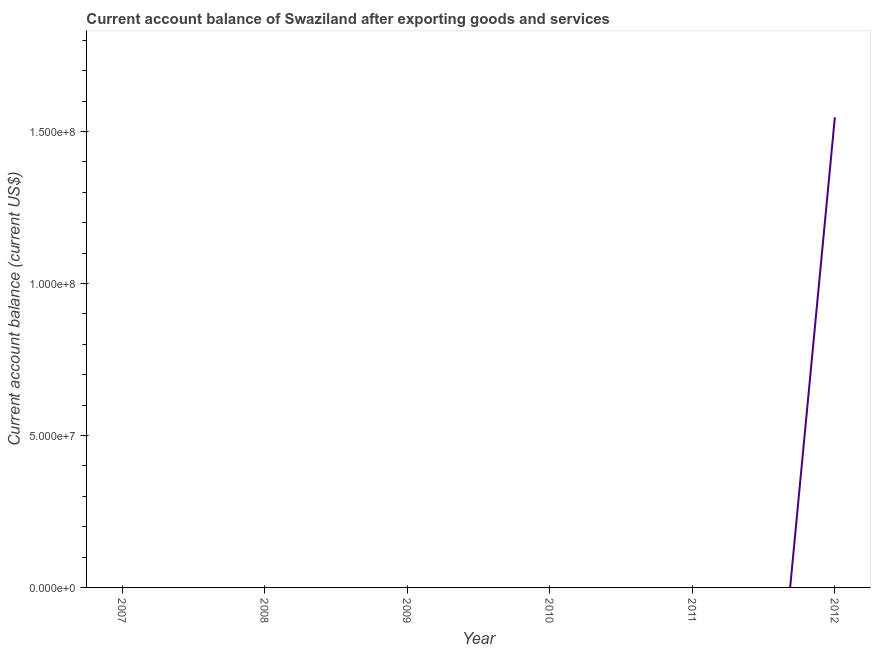What is the current account balance in 2009?
Your response must be concise. 0. Across all years, what is the maximum current account balance?
Ensure brevity in your answer.  1.55e+08. Across all years, what is the minimum current account balance?
Offer a terse response. 0. What is the sum of the current account balance?
Your response must be concise. 1.55e+08. What is the average current account balance per year?
Your answer should be compact. 2.58e+07. What is the difference between the highest and the lowest current account balance?
Make the answer very short. 1.55e+08. How many years are there in the graph?
Keep it short and to the point. 6. What is the difference between two consecutive major ticks on the Y-axis?
Ensure brevity in your answer.  5.00e+07. What is the title of the graph?
Keep it short and to the point. Current account balance of Swaziland after exporting goods and services. What is the label or title of the Y-axis?
Ensure brevity in your answer.  Current account balance (current US$). What is the Current account balance (current US$) in 2008?
Provide a short and direct response. 0. What is the Current account balance (current US$) in 2011?
Make the answer very short. 0. What is the Current account balance (current US$) of 2012?
Keep it short and to the point. 1.55e+08. 